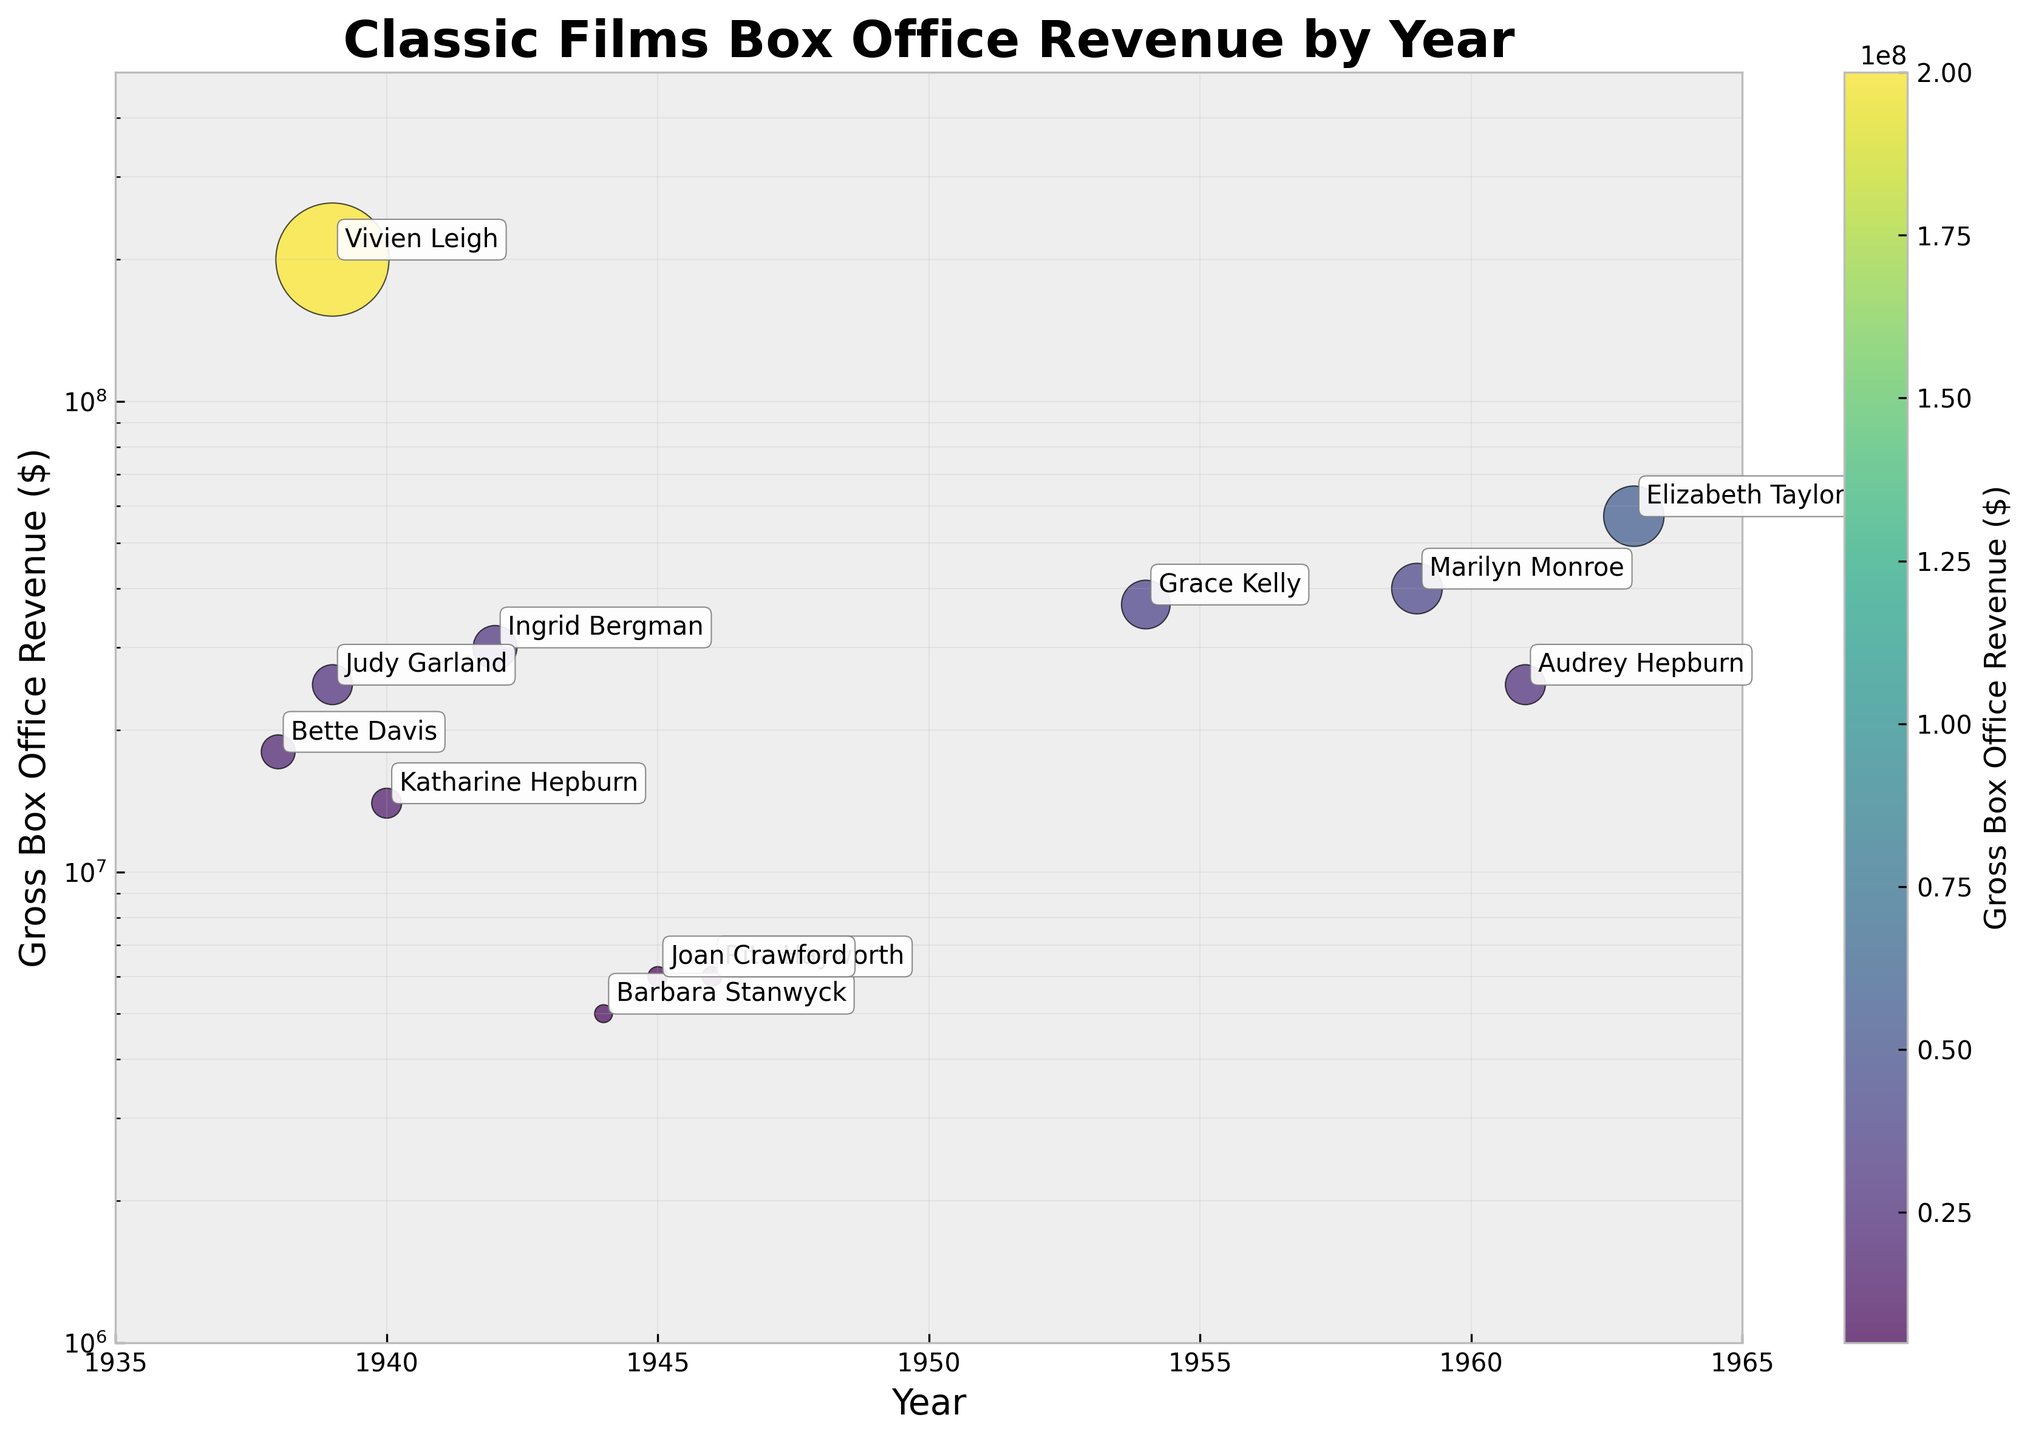What is the title of the scatter plot? The title is usually displayed at the top of the plot and summarizes what the visual is about. In this case, the title is written in a large, bold font.
Answer: Classic Films Box Office Revenue by Year Which year had the highest gross box office revenue, and which actress was associated with it? One can identify the highest point on the vertical axis (Gross Box Office Revenue) and look at the annotation for that point to determine the year and the actress involved.
Answer: 1939, Vivien Leigh How many data points were plotted between the years 1935 and 1965? Count the number of scatter points within the x-axis limits set from 1935 to 1965, as specified in the range.
Answer: 12 What is the gross box office revenue range represented on the log scale y-axis? The y-axis is a logarithmic scale which means it spans several orders of magnitude. The range can be determined by looking at the axis ticks and the scale.
Answer: 1 million to 500 million dollars How does the box office revenue of "The Wizard of Oz" compare to "Double Indemnity"? Locate both points on the scatter plot and compare their y-axis positions to understand which one is higher. The annotations help identify the respective films and their revenues.
Answer: "The Wizard of Oz" had higher box office revenue than "Double Indemnity" What range of years does the scatter plot cover, and within how many years did these classic films span? The x-axis represents years, and noting the smallest and largest year values gives the range.
Answer: The plot covers from 1938 to 1963, spanning 25 years Which actresses had their movies with the gross box office revenue below 10 million dollars? Identify the points on the log scale y-axis that lie below 10 million dollars and look at the annotations for these points to determine the actresses.
Answer: Barbara Stanwyck, Joan Crawford, Rita Hayworth What color gradient is used in the scatter plot, and what does it represent? The scatter plot uses color to convey information. By examining the color gradient, assess what it represents, which in this case would align with the color bar's label.
Answer: Viridis gradient, representing Gross Box Office Revenue Which film released in the 1950s had the highest gross box office revenue? Look for points in the scatter plot within the 1950s (1950-1959) on the x-axis and then find the one with the highest position on the y-axis.
Answer: Rear Window If you average the box office revenue of all films released in the 1940s, what would the value be? Locate all the points on the plot from the 1940s, sum their y-axis values (gross box office revenue), and divide by the number of such points to get the average. For the 1940s, films and their revenues are: The Philadelphia Story (14,000,000), Casablanca (30,000,000), Double Indemnity (5,000,000), Gilda (6,000,000), and Mildred Pierce (6,000,000). The sum is 61,000,000. Average = 61,000,000 / 5
Answer: 12,200,000 